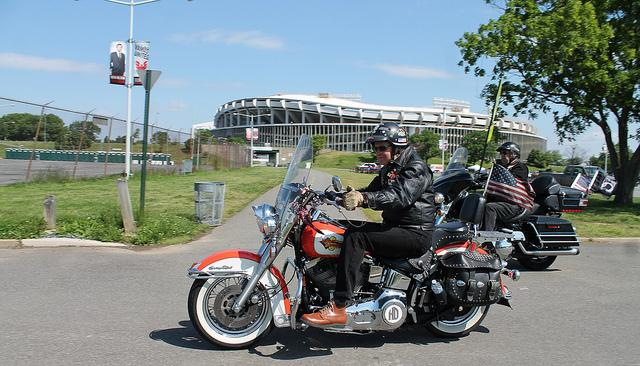What color is the rubber surrounding the outer rim of the tire on these bikes? Please explain your reasoning. white. I would have said black but it specifically says the "outer rim," which is why i chose the only other possible color. 